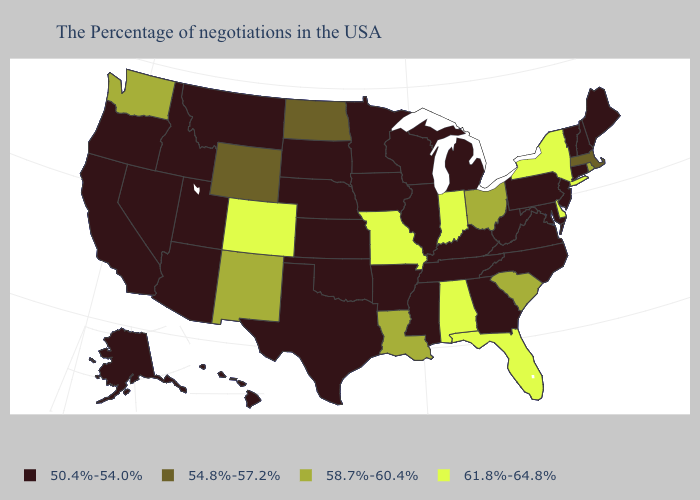What is the value of Minnesota?
Concise answer only. 50.4%-54.0%. Does the map have missing data?
Concise answer only. No. Name the states that have a value in the range 58.7%-60.4%?
Quick response, please. Rhode Island, South Carolina, Ohio, Louisiana, New Mexico, Washington. What is the value of Rhode Island?
Be succinct. 58.7%-60.4%. What is the value of Maryland?
Give a very brief answer. 50.4%-54.0%. Among the states that border Oregon , does Idaho have the highest value?
Answer briefly. No. Name the states that have a value in the range 61.8%-64.8%?
Short answer required. New York, Delaware, Florida, Indiana, Alabama, Missouri, Colorado. How many symbols are there in the legend?
Keep it brief. 4. Name the states that have a value in the range 58.7%-60.4%?
Concise answer only. Rhode Island, South Carolina, Ohio, Louisiana, New Mexico, Washington. Does Wisconsin have the same value as Oklahoma?
Keep it brief. Yes. What is the value of Kentucky?
Short answer required. 50.4%-54.0%. What is the value of Iowa?
Concise answer only. 50.4%-54.0%. What is the highest value in the USA?
Answer briefly. 61.8%-64.8%. Does Rhode Island have a higher value than Hawaii?
Answer briefly. Yes. What is the lowest value in the West?
Keep it brief. 50.4%-54.0%. 